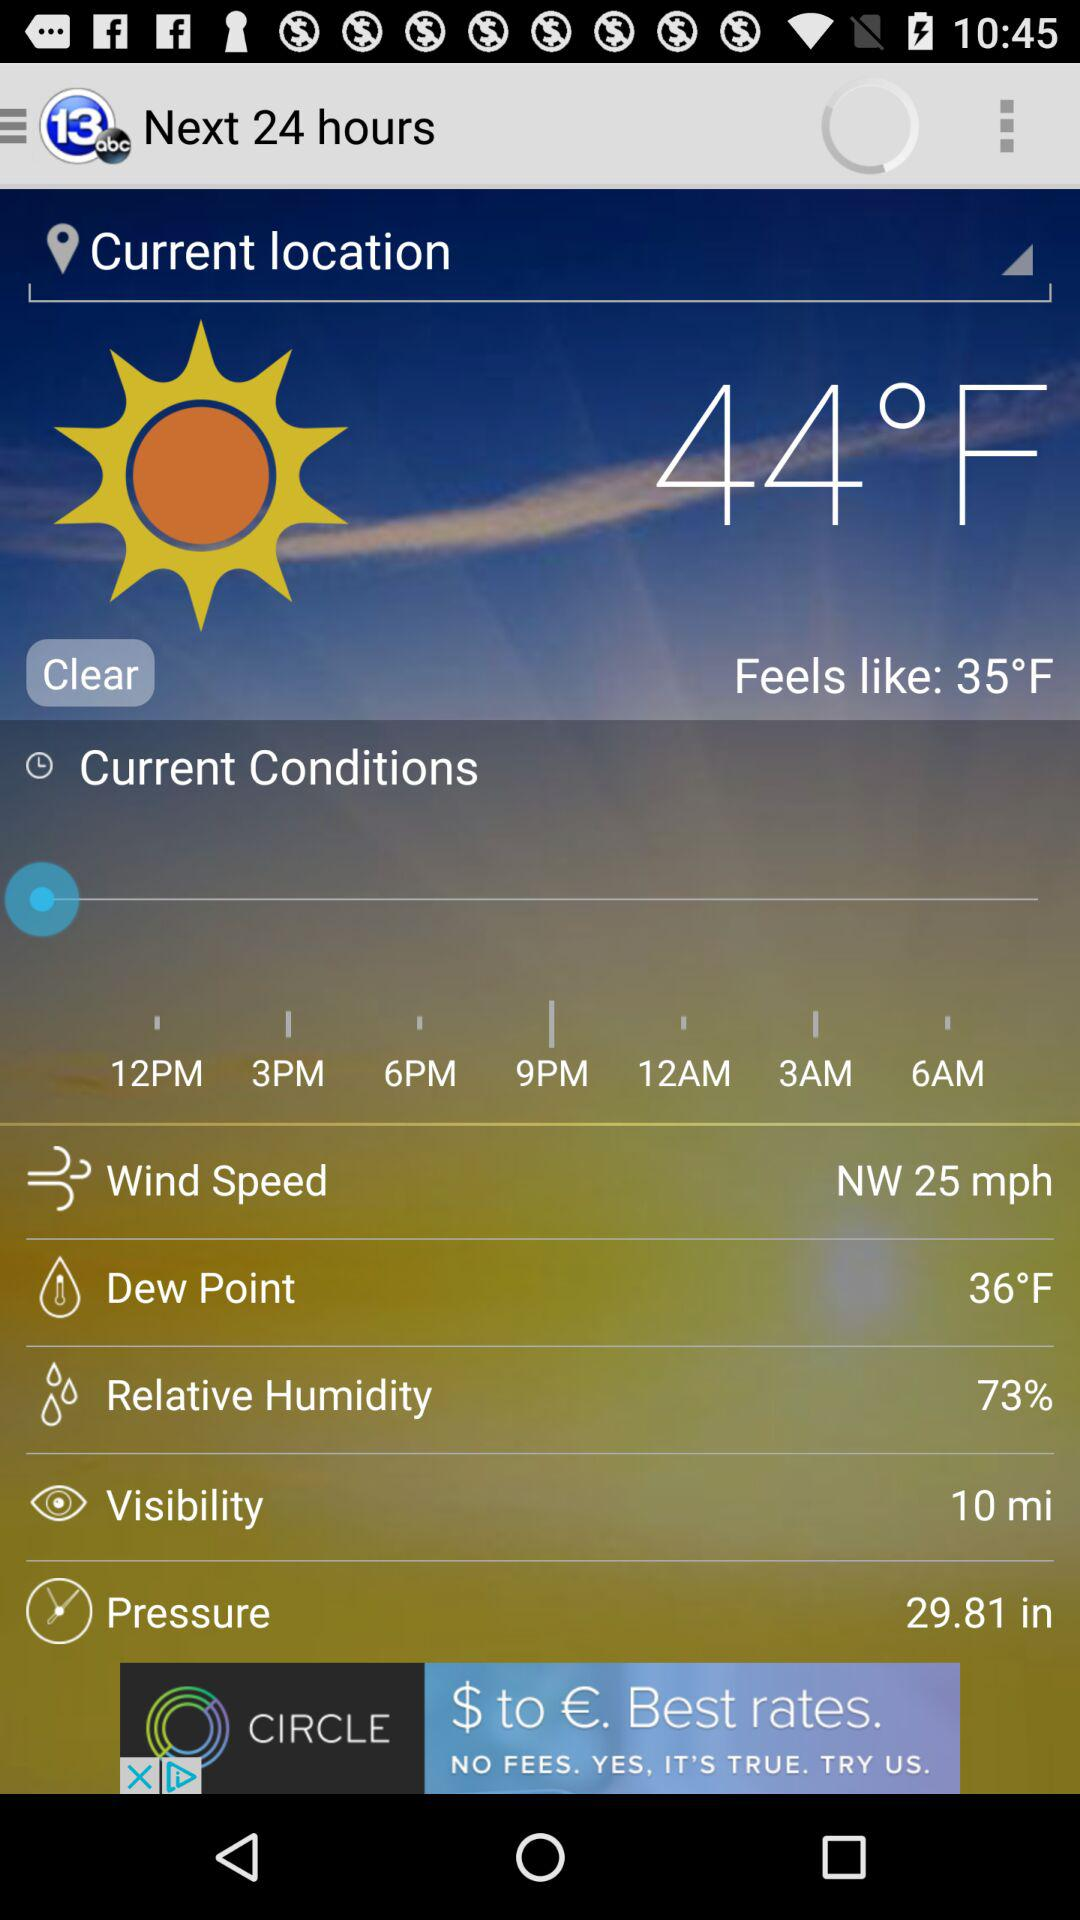What is the current temperature? The current temperature is 44 °F. 